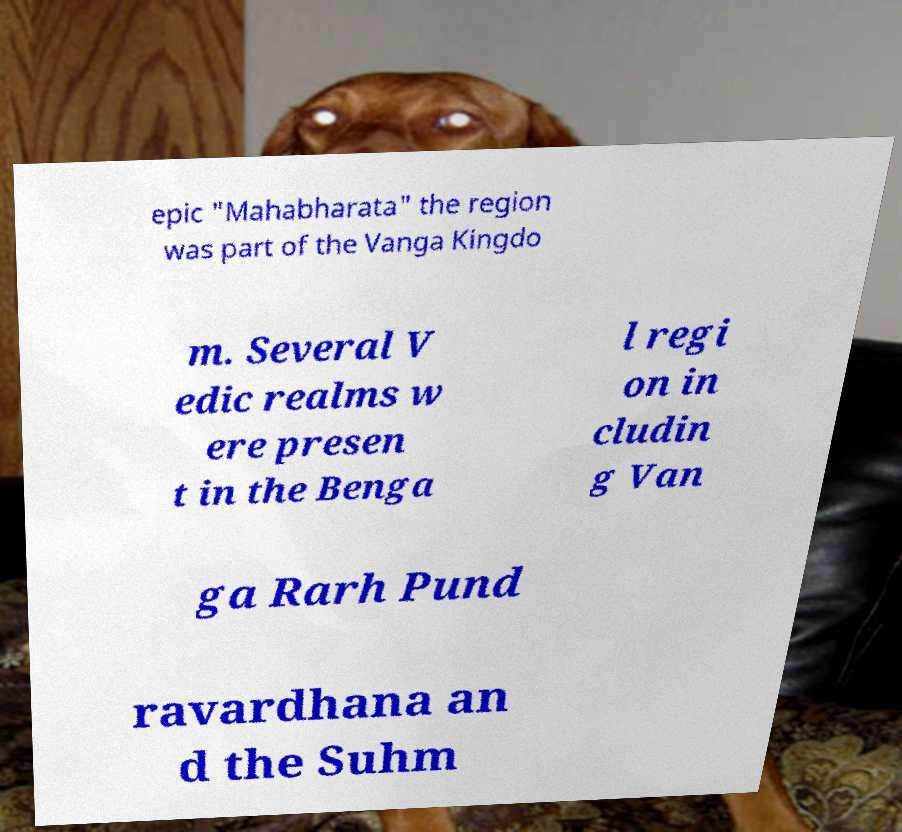Can you read and provide the text displayed in the image?This photo seems to have some interesting text. Can you extract and type it out for me? epic "Mahabharata" the region was part of the Vanga Kingdo m. Several V edic realms w ere presen t in the Benga l regi on in cludin g Van ga Rarh Pund ravardhana an d the Suhm 